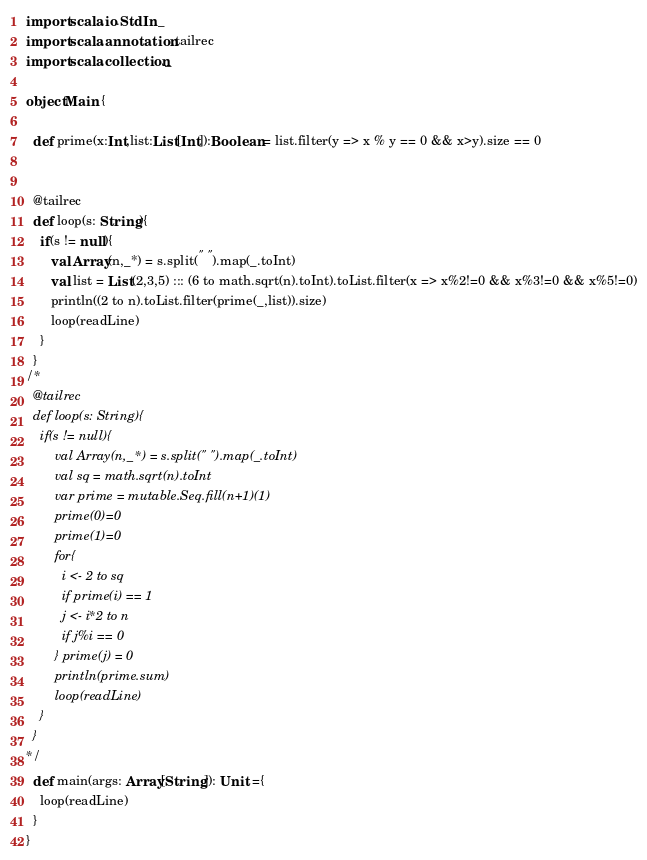Convert code to text. <code><loc_0><loc_0><loc_500><loc_500><_Scala_>import scala.io.StdIn._
import scala.annotation.tailrec
import scala.collection._

object Main {

  def prime(x:Int,list:List[Int]):Boolean = list.filter(y => x % y == 0 && x>y).size == 0


  @tailrec
  def loop(s: String){
    if(s != null){
       val Array(n,_*) = s.split(" ").map(_.toInt)
       val list = List(2,3,5) ::: (6 to math.sqrt(n).toInt).toList.filter(x => x%2!=0 && x%3!=0 && x%5!=0)
       println((2 to n).toList.filter(prime(_,list)).size)
       loop(readLine)
    }
  }
/*
  @tailrec
  def loop(s: String){
    if(s != null){
        val Array(n,_*) = s.split(" ").map(_.toInt)
        val sq = math.sqrt(n).toInt
        var prime = mutable.Seq.fill(n+1)(1)
        prime(0)=0
        prime(1)=0
        for{
          i <- 2 to sq
          if prime(i) == 1
          j <- i*2 to n
          if j%i == 0
        } prime(j) = 0
        println(prime.sum)
        loop(readLine)
    }
  }
*/
  def main(args: Array[String]): Unit ={
    loop(readLine)
  }
}</code> 